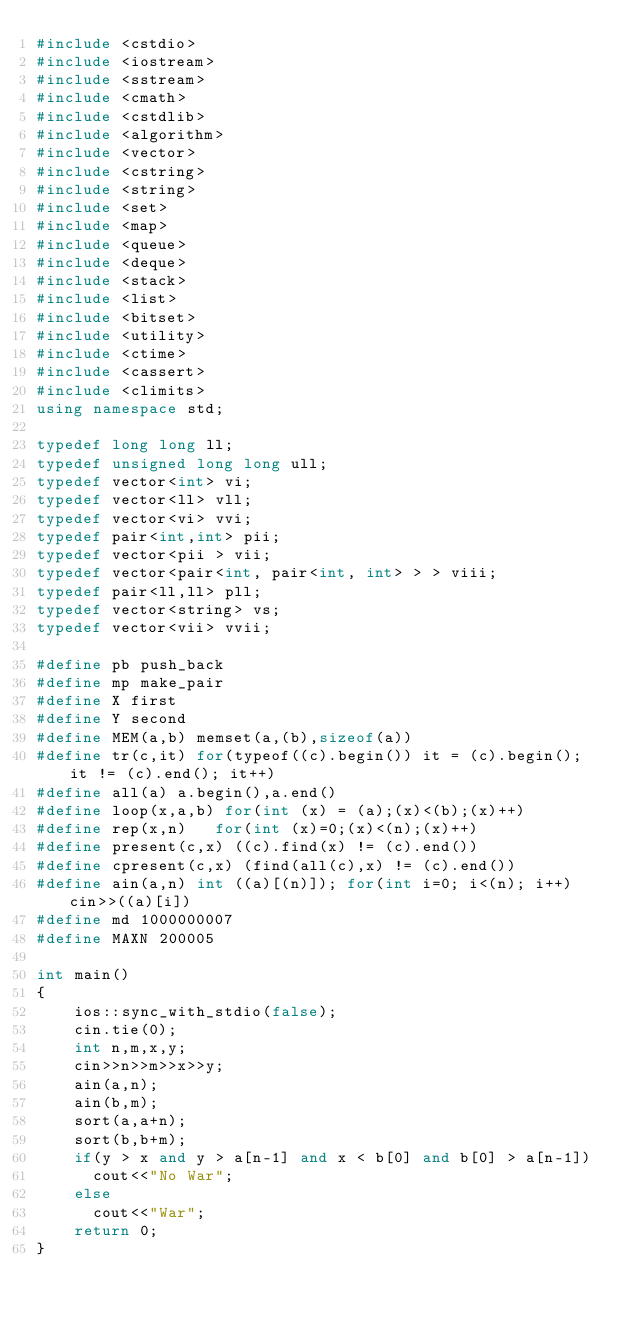Convert code to text. <code><loc_0><loc_0><loc_500><loc_500><_C++_>#include <cstdio>
#include <iostream>
#include <sstream>
#include <cmath>
#include <cstdlib>
#include <algorithm>
#include <vector>
#include <cstring>
#include <string>
#include <set>
#include <map>
#include <queue>
#include <deque>
#include <stack>
#include <list>
#include <bitset>
#include <utility>
#include <ctime>
#include <cassert>
#include <climits>
using namespace std;

typedef long long ll;
typedef unsigned long long ull;
typedef vector<int> vi;
typedef vector<ll> vll;
typedef vector<vi> vvi;
typedef pair<int,int> pii;
typedef vector<pii > vii;
typedef vector<pair<int, pair<int, int> > > viii;
typedef pair<ll,ll> pll;
typedef vector<string> vs;
typedef vector<vii> vvii;

#define pb push_back
#define mp make_pair
#define X first
#define Y second
#define MEM(a,b) memset(a,(b),sizeof(a))
#define tr(c,it) for(typeof((c).begin()) it = (c).begin(); it != (c).end(); it++)
#define all(a) a.begin(),a.end()
#define loop(x,a,b) for(int (x) = (a);(x)<(b);(x)++)
#define rep(x,n)   for(int (x)=0;(x)<(n);(x)++)
#define present(c,x) ((c).find(x) != (c).end()) 
#define cpresent(c,x) (find(all(c),x) != (c).end())
#define ain(a,n) int ((a)[(n)]); for(int i=0; i<(n); i++) cin>>((a)[i])  
#define md 1000000007
#define MAXN 200005

int main()
{   
    ios::sync_with_stdio(false);
    cin.tie(0);
    int n,m,x,y;
    cin>>n>>m>>x>>y;
    ain(a,n);
    ain(b,m);
    sort(a,a+n);
    sort(b,b+m);
    if(y > x and y > a[n-1] and x < b[0] and b[0] > a[n-1])
    	cout<<"No War";
    else 
    	cout<<"War";
    return 0;
}
</code> 